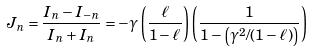<formula> <loc_0><loc_0><loc_500><loc_500>J _ { n } = \frac { I _ { n } - I _ { - n } } { I _ { n } + I _ { n } } = - \gamma \left ( \frac { \ell } { 1 - \ell } \right ) \left ( \frac { 1 } { 1 - \left ( \gamma ^ { 2 } / ( 1 - \ell ) \right ) } \right )</formula> 